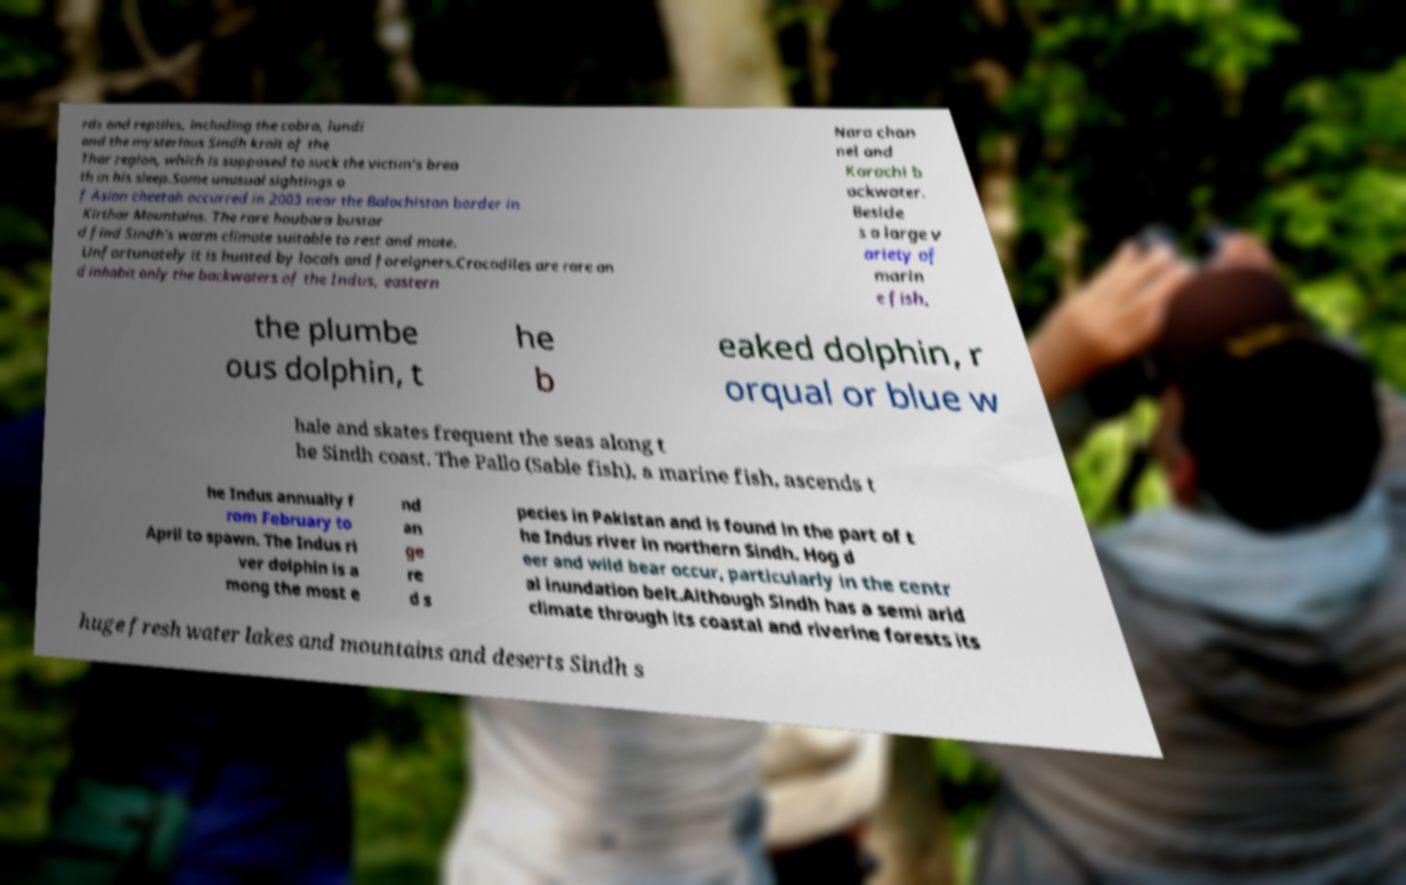Can you read and provide the text displayed in the image?This photo seems to have some interesting text. Can you extract and type it out for me? rds and reptiles, including the cobra, lundi and the mysterious Sindh krait of the Thar region, which is supposed to suck the victim's brea th in his sleep.Some unusual sightings o f Asian cheetah occurred in 2003 near the Balochistan border in Kirthar Mountains. The rare houbara bustar d find Sindh's warm climate suitable to rest and mate. Unfortunately it is hunted by locals and foreigners.Crocodiles are rare an d inhabit only the backwaters of the Indus, eastern Nara chan nel and Karachi b ackwater. Beside s a large v ariety of marin e fish, the plumbe ous dolphin, t he b eaked dolphin, r orqual or blue w hale and skates frequent the seas along t he Sindh coast. The Pallo (Sable fish), a marine fish, ascends t he Indus annually f rom February to April to spawn. The Indus ri ver dolphin is a mong the most e nd an ge re d s pecies in Pakistan and is found in the part of t he Indus river in northern Sindh. Hog d eer and wild bear occur, particularly in the centr al inundation belt.Although Sindh has a semi arid climate through its coastal and riverine forests its huge fresh water lakes and mountains and deserts Sindh s 